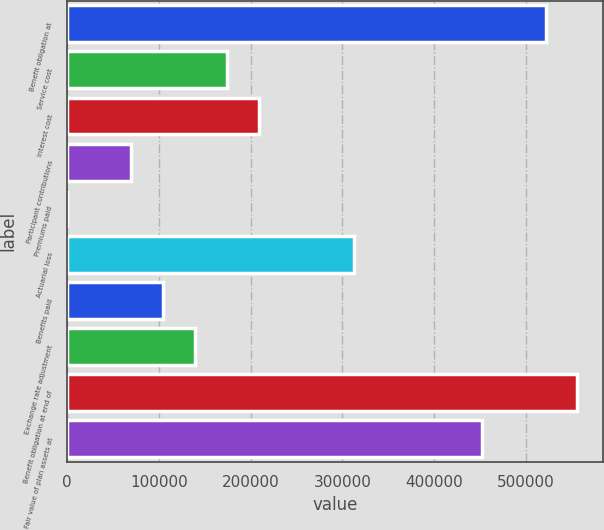<chart> <loc_0><loc_0><loc_500><loc_500><bar_chart><fcel>Benefit obligation at<fcel>Service cost<fcel>Interest cost<fcel>Participant contributions<fcel>Premiums paid<fcel>Actuarial loss<fcel>Benefits paid<fcel>Exchange rate adjustment<fcel>Benefit obligation at end of<fcel>Fair value of plan assets at<nl><fcel>521376<fcel>173954<fcel>208697<fcel>69728.2<fcel>244<fcel>312923<fcel>104470<fcel>139212<fcel>556118<fcel>451891<nl></chart> 